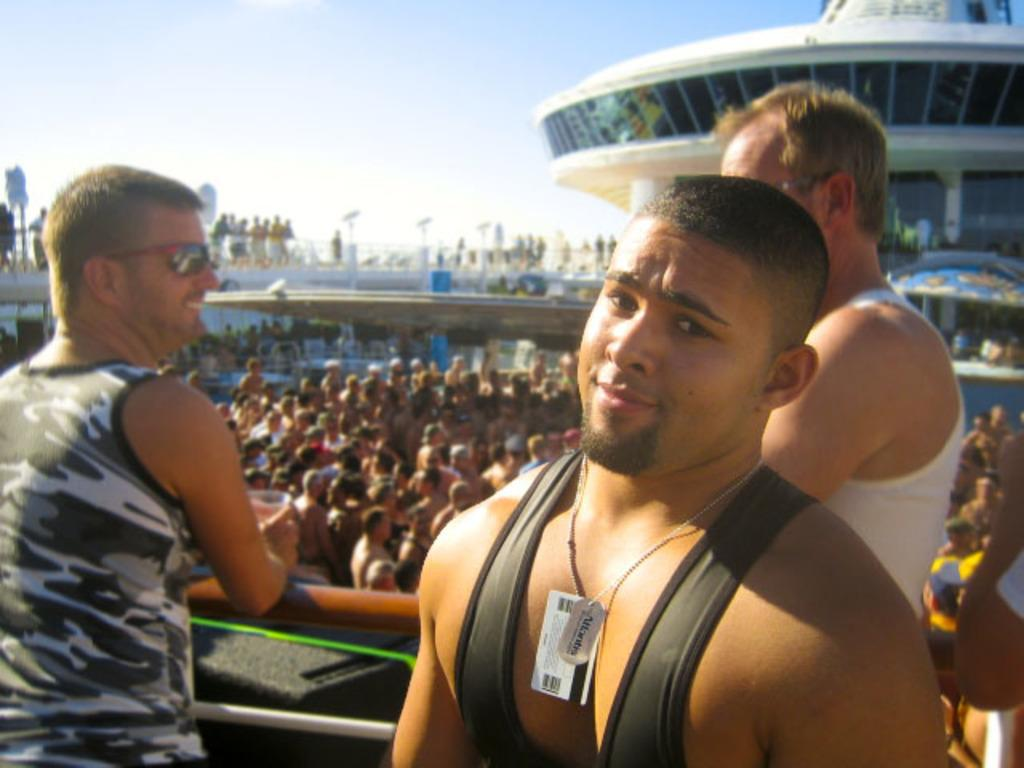How many men are present in the image? There are three men standing in the image. What can be seen besides the men in the image? There appears to be an iron pole and a group of people in the image. What type of structure is present in the image? There is a building with glass doors in the image. Can you describe the possible setting of the image? The image may depict a bridge. What type of lipstick is the giraffe wearing in the image? There is no giraffe present in the image, and therefore no lipstick or giraffe can be observed. 